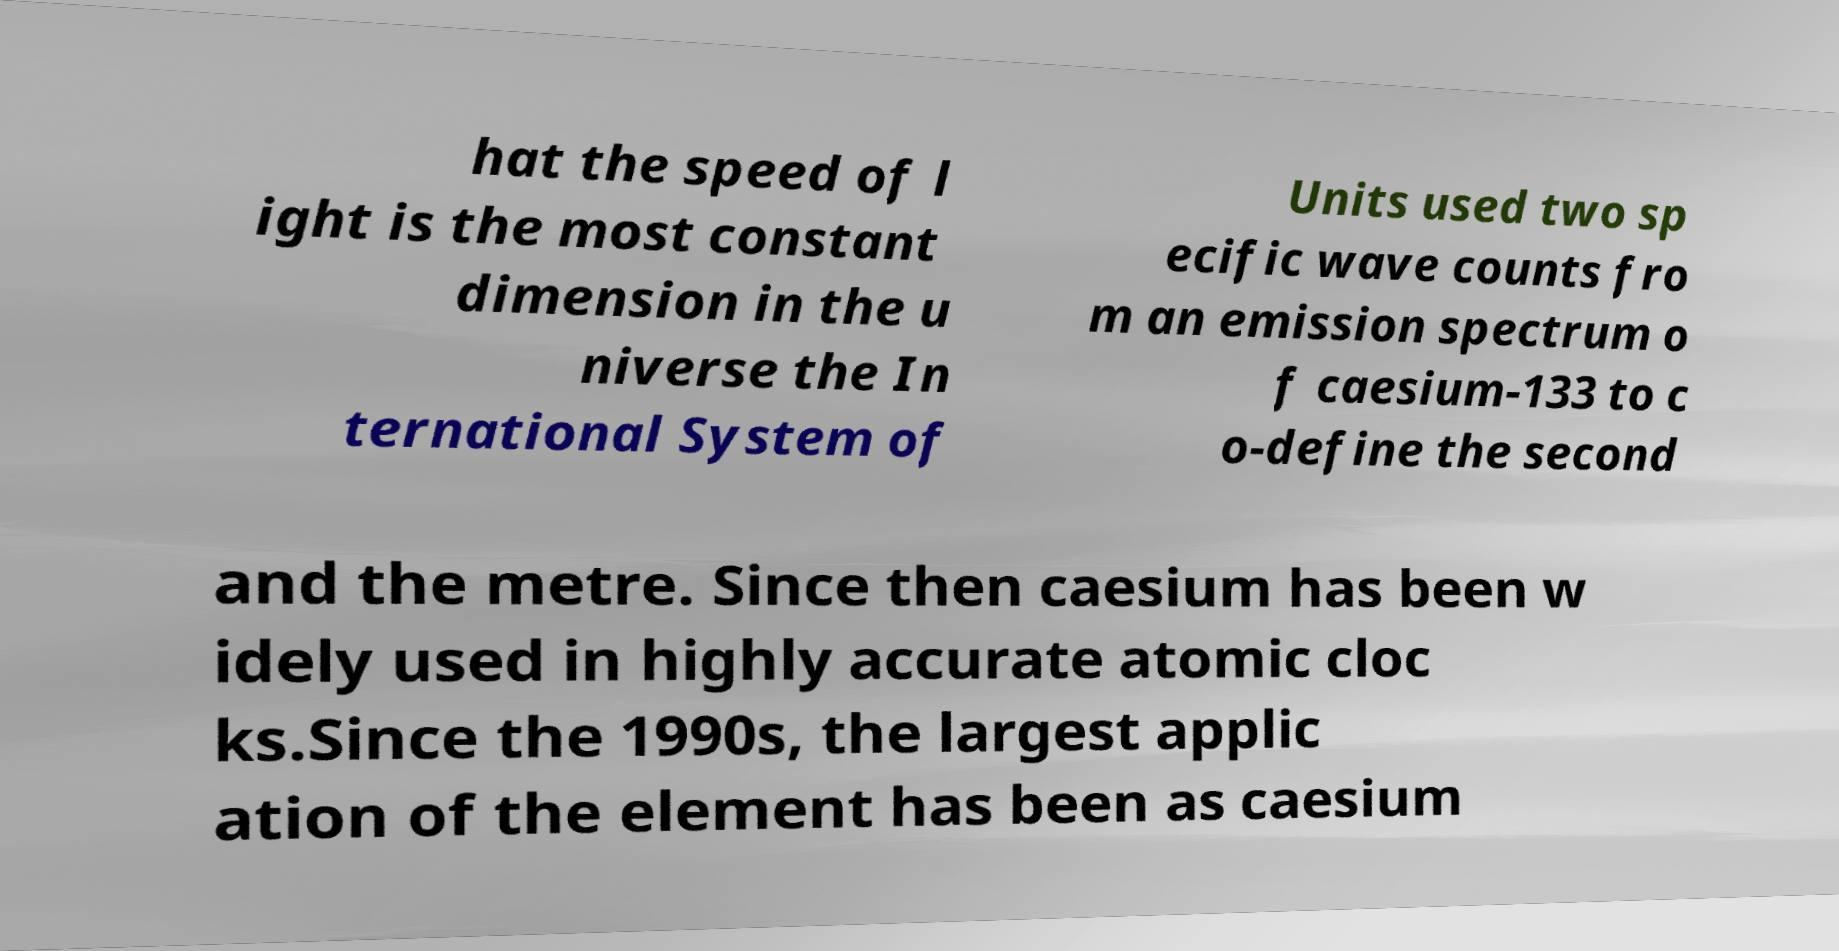Please identify and transcribe the text found in this image. hat the speed of l ight is the most constant dimension in the u niverse the In ternational System of Units used two sp ecific wave counts fro m an emission spectrum o f caesium-133 to c o-define the second and the metre. Since then caesium has been w idely used in highly accurate atomic cloc ks.Since the 1990s, the largest applic ation of the element has been as caesium 